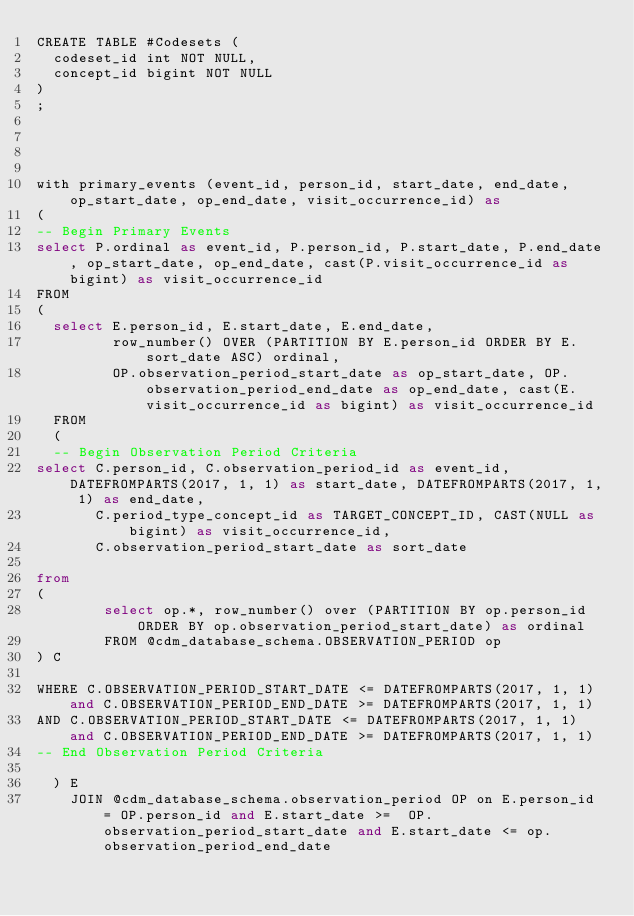<code> <loc_0><loc_0><loc_500><loc_500><_SQL_>CREATE TABLE #Codesets (
  codeset_id int NOT NULL,
  concept_id bigint NOT NULL
)
;




with primary_events (event_id, person_id, start_date, end_date, op_start_date, op_end_date, visit_occurrence_id) as
(
-- Begin Primary Events
select P.ordinal as event_id, P.person_id, P.start_date, P.end_date, op_start_date, op_end_date, cast(P.visit_occurrence_id as bigint) as visit_occurrence_id
FROM
(
  select E.person_id, E.start_date, E.end_date,
         row_number() OVER (PARTITION BY E.person_id ORDER BY E.sort_date ASC) ordinal,
         OP.observation_period_start_date as op_start_date, OP.observation_period_end_date as op_end_date, cast(E.visit_occurrence_id as bigint) as visit_occurrence_id
  FROM 
  (
  -- Begin Observation Period Criteria
select C.person_id, C.observation_period_id as event_id, DATEFROMPARTS(2017, 1, 1) as start_date, DATEFROMPARTS(2017, 1, 1) as end_date,
       C.period_type_concept_id as TARGET_CONCEPT_ID, CAST(NULL as bigint) as visit_occurrence_id,
       C.observation_period_start_date as sort_date

from 
(
        select op.*, row_number() over (PARTITION BY op.person_id ORDER BY op.observation_period_start_date) as ordinal
        FROM @cdm_database_schema.OBSERVATION_PERIOD op
) C

WHERE C.OBSERVATION_PERIOD_START_DATE <= DATEFROMPARTS(2017, 1, 1) and C.OBSERVATION_PERIOD_END_DATE >= DATEFROMPARTS(2017, 1, 1)
AND C.OBSERVATION_PERIOD_START_DATE <= DATEFROMPARTS(2017, 1, 1) and C.OBSERVATION_PERIOD_END_DATE >= DATEFROMPARTS(2017, 1, 1)
-- End Observation Period Criteria

  ) E
	JOIN @cdm_database_schema.observation_period OP on E.person_id = OP.person_id and E.start_date >=  OP.observation_period_start_date and E.start_date <= op.observation_period_end_date</code> 